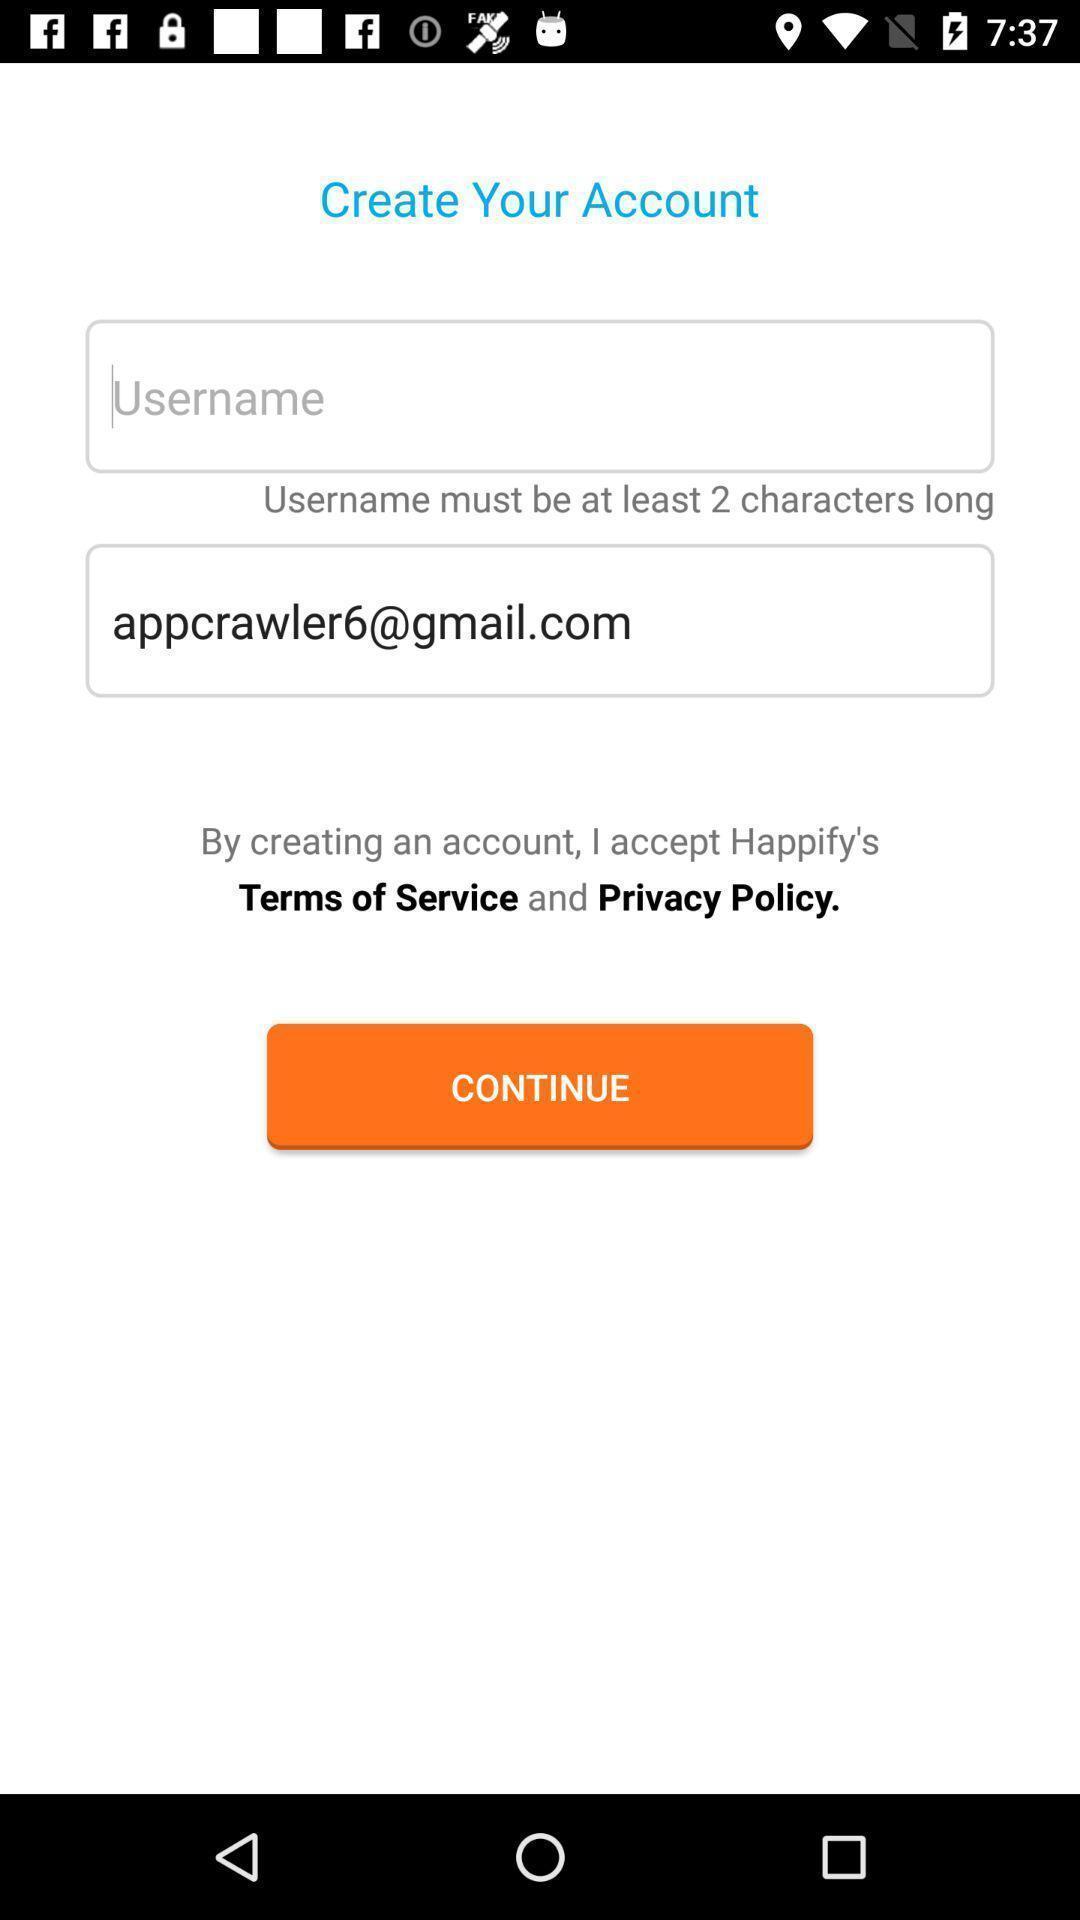Give me a narrative description of this picture. Page displaying to create account for an app. 